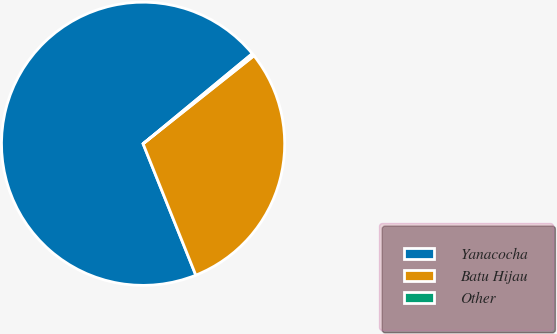Convert chart. <chart><loc_0><loc_0><loc_500><loc_500><pie_chart><fcel>Yanacocha<fcel>Batu Hijau<fcel>Other<nl><fcel>70.09%<fcel>29.61%<fcel>0.3%<nl></chart> 